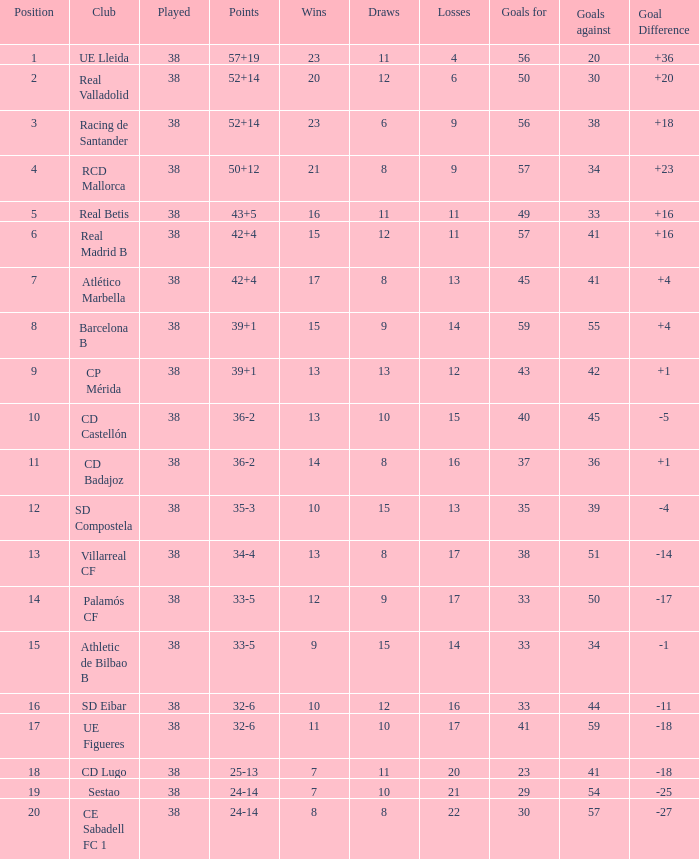What is the average goal difference with 51 goals scored against and less than 17 losses? None. 